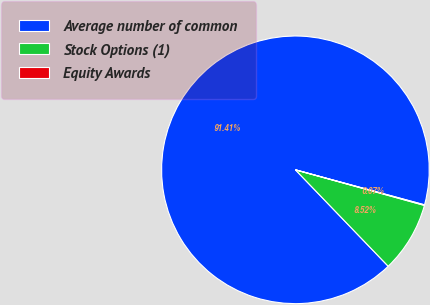<chart> <loc_0><loc_0><loc_500><loc_500><pie_chart><fcel>Average number of common<fcel>Stock Options (1)<fcel>Equity Awards<nl><fcel>91.41%<fcel>8.52%<fcel>0.07%<nl></chart> 